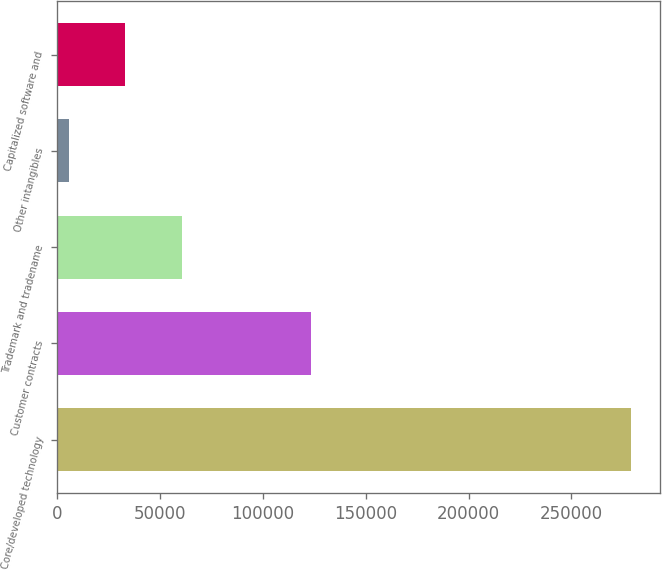Convert chart. <chart><loc_0><loc_0><loc_500><loc_500><bar_chart><fcel>Core/developed technology<fcel>Customer contracts<fcel>Trademark and tradename<fcel>Other intangibles<fcel>Capitalized software and<nl><fcel>279110<fcel>123540<fcel>60616.4<fcel>5993<fcel>33304.7<nl></chart> 